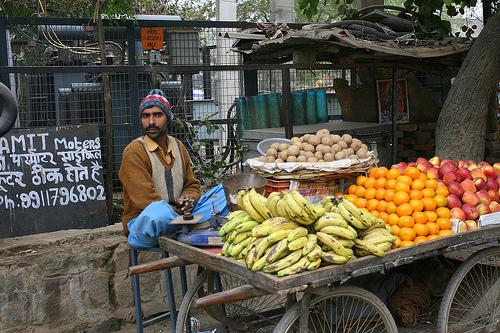Question: what is on the cart?
Choices:
A. Boxes.
B. Toys.
C. Fruit.
D. Vegetables.
Answer with the letter. Answer: C Question: what color are the man's pants?
Choices:
A. Green.
B. Brown.
C. Black.
D. Blue.
Answer with the letter. Answer: D Question: how is the person sitting?
Choices:
A. Upright.
B. Cross-legged.
C. Reclined back.
D. On the chair.
Answer with the letter. Answer: B Question: why is there fruit on the cart?
Choices:
A. It has been sold.
B. It is for sale.
C. It is being moved.
D. It needs thrown out.
Answer with the letter. Answer: B Question: what color are the oranges?
Choices:
A. Yellow.
B. Orange.
C. Green.
D. Black.
Answer with the letter. Answer: B Question: who is sitting by the cart?
Choices:
A. The clerk.
B. The man.
C. The children.
D. The manager.
Answer with the letter. Answer: B 